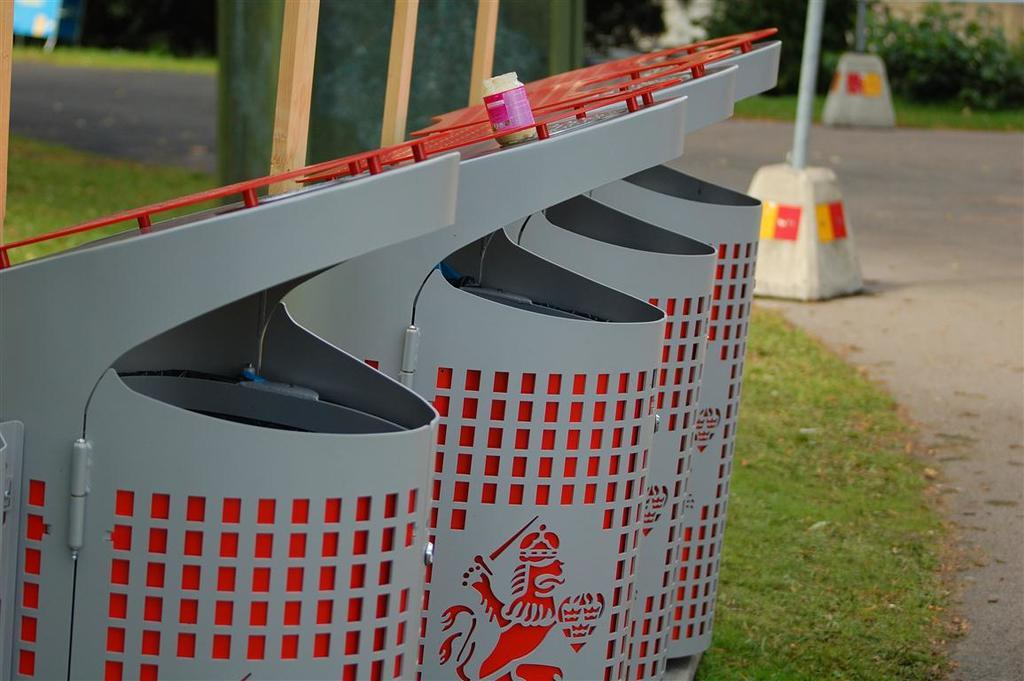What objects are located on the left side of the image? There are bins on the left side of the image. What is placed on top of the bins? There is a jar on the bins. What type of vegetation can be seen in the background of the image? There is grass on the ground in the background of the image. What type of man-made structure is visible in the background of the image? There is a road visible in the background of the image. What other natural elements can be seen in the background of the image? There are plants in the background of the image. What type of structures are present on platforms in the background of the image? There are poles on platforms in the background of the image. What type of crime is being committed in the image? There is no indication of any crime being committed in the image. How long does it take for the minute to pass in the image? The concept of time passing is not depicted in the image, so it is not possible to determine how long a minute takes. 